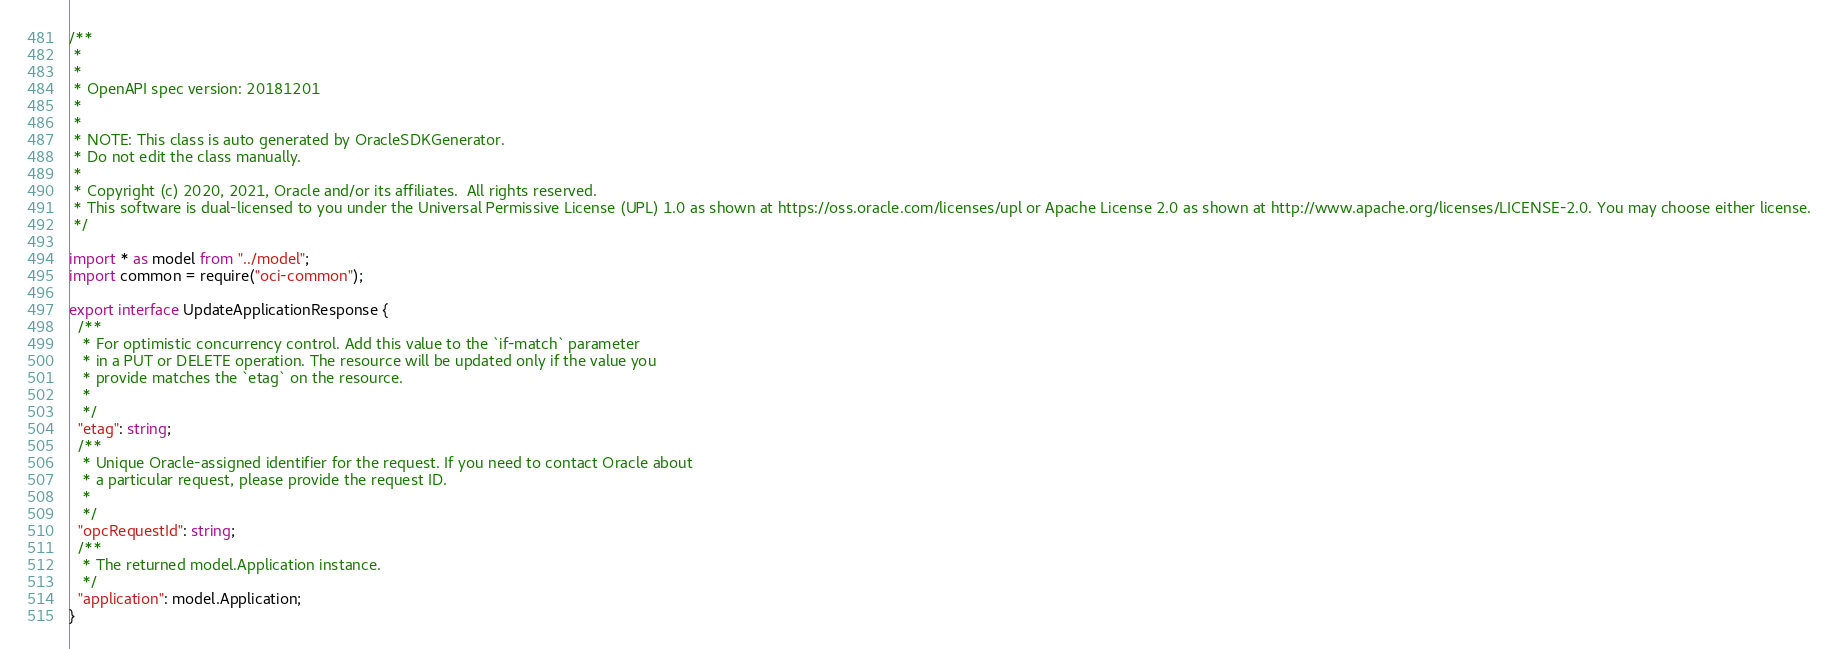Convert code to text. <code><loc_0><loc_0><loc_500><loc_500><_TypeScript_>/**
 *
 *
 * OpenAPI spec version: 20181201
 *
 *
 * NOTE: This class is auto generated by OracleSDKGenerator.
 * Do not edit the class manually.
 *
 * Copyright (c) 2020, 2021, Oracle and/or its affiliates.  All rights reserved.
 * This software is dual-licensed to you under the Universal Permissive License (UPL) 1.0 as shown at https://oss.oracle.com/licenses/upl or Apache License 2.0 as shown at http://www.apache.org/licenses/LICENSE-2.0. You may choose either license.
 */

import * as model from "../model";
import common = require("oci-common");

export interface UpdateApplicationResponse {
  /**
   * For optimistic concurrency control. Add this value to the `if-match` parameter
   * in a PUT or DELETE operation. The resource will be updated only if the value you
   * provide matches the `etag` on the resource.
   *
   */
  "etag": string;
  /**
   * Unique Oracle-assigned identifier for the request. If you need to contact Oracle about
   * a particular request, please provide the request ID.
   *
   */
  "opcRequestId": string;
  /**
   * The returned model.Application instance.
   */
  "application": model.Application;
}
</code> 